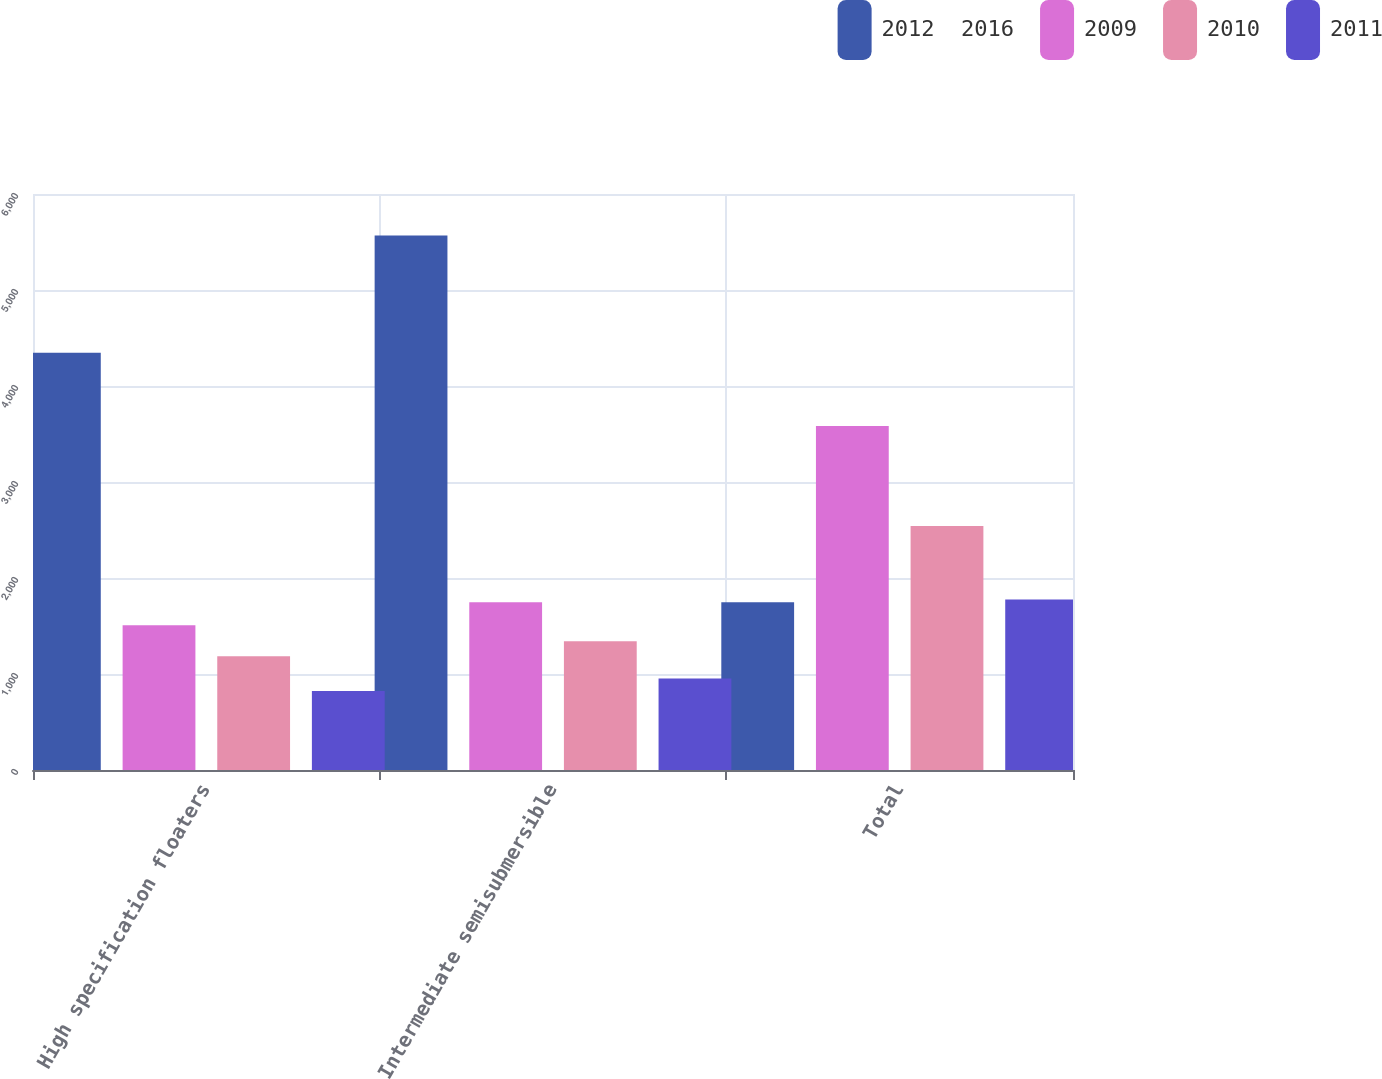<chart> <loc_0><loc_0><loc_500><loc_500><stacked_bar_chart><ecel><fcel>High specification floaters<fcel>Intermediate semisubmersible<fcel>Total<nl><fcel>2012  2016<fcel>4346<fcel>5567<fcel>1747<nl><fcel>2009<fcel>1507<fcel>1747<fcel>3583<nl><fcel>2010<fcel>1185<fcel>1340<fcel>2542<nl><fcel>2011<fcel>822<fcel>953<fcel>1775<nl></chart> 